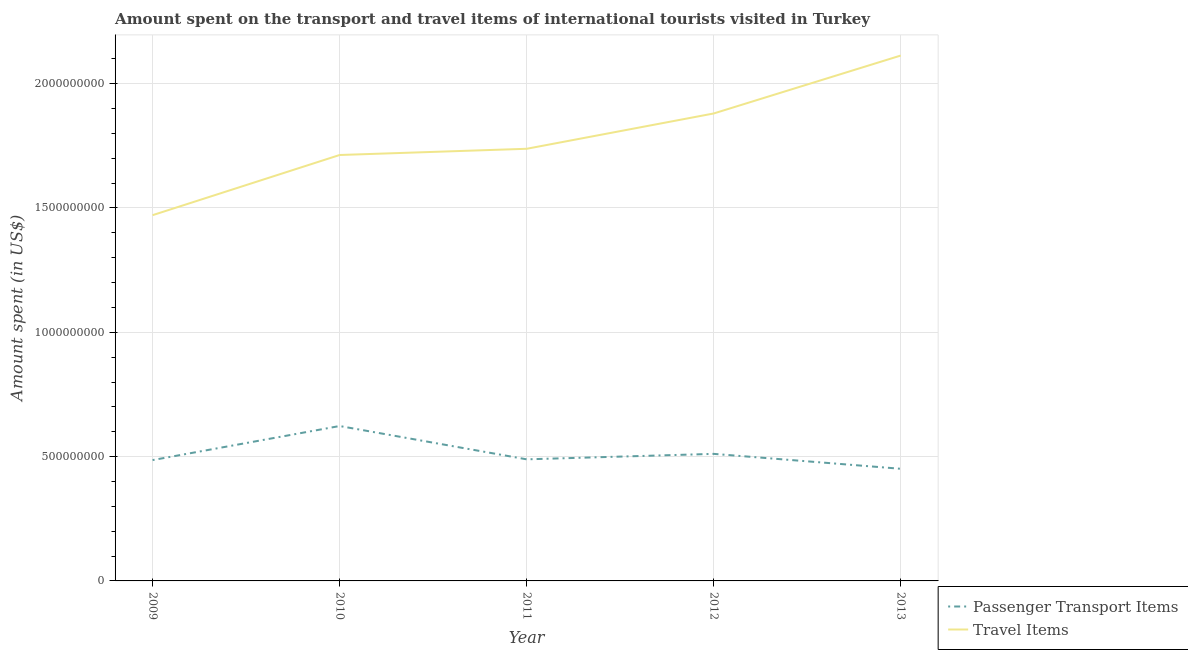How many different coloured lines are there?
Your answer should be compact. 2. Does the line corresponding to amount spent on passenger transport items intersect with the line corresponding to amount spent in travel items?
Provide a succinct answer. No. Is the number of lines equal to the number of legend labels?
Ensure brevity in your answer.  Yes. What is the amount spent on passenger transport items in 2010?
Your response must be concise. 6.23e+08. Across all years, what is the maximum amount spent on passenger transport items?
Give a very brief answer. 6.23e+08. Across all years, what is the minimum amount spent in travel items?
Your answer should be compact. 1.47e+09. What is the total amount spent in travel items in the graph?
Keep it short and to the point. 8.92e+09. What is the difference between the amount spent in travel items in 2010 and that in 2012?
Provide a succinct answer. -1.67e+08. What is the difference between the amount spent on passenger transport items in 2012 and the amount spent in travel items in 2010?
Make the answer very short. -1.20e+09. What is the average amount spent in travel items per year?
Offer a terse response. 1.78e+09. In the year 2011, what is the difference between the amount spent in travel items and amount spent on passenger transport items?
Keep it short and to the point. 1.25e+09. What is the ratio of the amount spent in travel items in 2010 to that in 2011?
Your response must be concise. 0.99. Is the difference between the amount spent in travel items in 2011 and 2012 greater than the difference between the amount spent on passenger transport items in 2011 and 2012?
Your answer should be very brief. No. What is the difference between the highest and the second highest amount spent in travel items?
Give a very brief answer. 2.33e+08. What is the difference between the highest and the lowest amount spent in travel items?
Provide a succinct answer. 6.42e+08. In how many years, is the amount spent on passenger transport items greater than the average amount spent on passenger transport items taken over all years?
Offer a very short reply. 1. Does the amount spent in travel items monotonically increase over the years?
Offer a terse response. Yes. Is the amount spent on passenger transport items strictly greater than the amount spent in travel items over the years?
Your response must be concise. No. How many lines are there?
Provide a short and direct response. 2. How many years are there in the graph?
Ensure brevity in your answer.  5. What is the difference between two consecutive major ticks on the Y-axis?
Your answer should be compact. 5.00e+08. Are the values on the major ticks of Y-axis written in scientific E-notation?
Your answer should be very brief. No. Does the graph contain any zero values?
Your answer should be very brief. No. Does the graph contain grids?
Ensure brevity in your answer.  Yes. Where does the legend appear in the graph?
Provide a short and direct response. Bottom right. How are the legend labels stacked?
Ensure brevity in your answer.  Vertical. What is the title of the graph?
Keep it short and to the point. Amount spent on the transport and travel items of international tourists visited in Turkey. What is the label or title of the X-axis?
Your answer should be very brief. Year. What is the label or title of the Y-axis?
Provide a short and direct response. Amount spent (in US$). What is the Amount spent (in US$) in Passenger Transport Items in 2009?
Provide a succinct answer. 4.86e+08. What is the Amount spent (in US$) in Travel Items in 2009?
Your answer should be compact. 1.47e+09. What is the Amount spent (in US$) in Passenger Transport Items in 2010?
Make the answer very short. 6.23e+08. What is the Amount spent (in US$) of Travel Items in 2010?
Offer a terse response. 1.71e+09. What is the Amount spent (in US$) of Passenger Transport Items in 2011?
Your response must be concise. 4.89e+08. What is the Amount spent (in US$) in Travel Items in 2011?
Offer a very short reply. 1.74e+09. What is the Amount spent (in US$) in Passenger Transport Items in 2012?
Offer a very short reply. 5.11e+08. What is the Amount spent (in US$) of Travel Items in 2012?
Offer a very short reply. 1.88e+09. What is the Amount spent (in US$) of Passenger Transport Items in 2013?
Make the answer very short. 4.51e+08. What is the Amount spent (in US$) in Travel Items in 2013?
Your answer should be very brief. 2.11e+09. Across all years, what is the maximum Amount spent (in US$) of Passenger Transport Items?
Provide a short and direct response. 6.23e+08. Across all years, what is the maximum Amount spent (in US$) of Travel Items?
Offer a terse response. 2.11e+09. Across all years, what is the minimum Amount spent (in US$) of Passenger Transport Items?
Your response must be concise. 4.51e+08. Across all years, what is the minimum Amount spent (in US$) of Travel Items?
Offer a very short reply. 1.47e+09. What is the total Amount spent (in US$) in Passenger Transport Items in the graph?
Make the answer very short. 2.56e+09. What is the total Amount spent (in US$) of Travel Items in the graph?
Your answer should be compact. 8.92e+09. What is the difference between the Amount spent (in US$) of Passenger Transport Items in 2009 and that in 2010?
Your response must be concise. -1.37e+08. What is the difference between the Amount spent (in US$) of Travel Items in 2009 and that in 2010?
Provide a short and direct response. -2.42e+08. What is the difference between the Amount spent (in US$) in Passenger Transport Items in 2009 and that in 2011?
Give a very brief answer. -3.00e+06. What is the difference between the Amount spent (in US$) of Travel Items in 2009 and that in 2011?
Your answer should be compact. -2.67e+08. What is the difference between the Amount spent (in US$) of Passenger Transport Items in 2009 and that in 2012?
Ensure brevity in your answer.  -2.50e+07. What is the difference between the Amount spent (in US$) in Travel Items in 2009 and that in 2012?
Your response must be concise. -4.09e+08. What is the difference between the Amount spent (in US$) of Passenger Transport Items in 2009 and that in 2013?
Make the answer very short. 3.50e+07. What is the difference between the Amount spent (in US$) in Travel Items in 2009 and that in 2013?
Your answer should be compact. -6.42e+08. What is the difference between the Amount spent (in US$) of Passenger Transport Items in 2010 and that in 2011?
Your answer should be very brief. 1.34e+08. What is the difference between the Amount spent (in US$) of Travel Items in 2010 and that in 2011?
Your answer should be compact. -2.50e+07. What is the difference between the Amount spent (in US$) of Passenger Transport Items in 2010 and that in 2012?
Provide a short and direct response. 1.12e+08. What is the difference between the Amount spent (in US$) in Travel Items in 2010 and that in 2012?
Keep it short and to the point. -1.67e+08. What is the difference between the Amount spent (in US$) of Passenger Transport Items in 2010 and that in 2013?
Your response must be concise. 1.72e+08. What is the difference between the Amount spent (in US$) in Travel Items in 2010 and that in 2013?
Offer a terse response. -4.00e+08. What is the difference between the Amount spent (in US$) in Passenger Transport Items in 2011 and that in 2012?
Offer a very short reply. -2.20e+07. What is the difference between the Amount spent (in US$) in Travel Items in 2011 and that in 2012?
Your response must be concise. -1.42e+08. What is the difference between the Amount spent (in US$) of Passenger Transport Items in 2011 and that in 2013?
Your answer should be very brief. 3.80e+07. What is the difference between the Amount spent (in US$) in Travel Items in 2011 and that in 2013?
Keep it short and to the point. -3.75e+08. What is the difference between the Amount spent (in US$) in Passenger Transport Items in 2012 and that in 2013?
Offer a terse response. 6.00e+07. What is the difference between the Amount spent (in US$) in Travel Items in 2012 and that in 2013?
Your answer should be very brief. -2.33e+08. What is the difference between the Amount spent (in US$) of Passenger Transport Items in 2009 and the Amount spent (in US$) of Travel Items in 2010?
Your answer should be very brief. -1.23e+09. What is the difference between the Amount spent (in US$) of Passenger Transport Items in 2009 and the Amount spent (in US$) of Travel Items in 2011?
Ensure brevity in your answer.  -1.25e+09. What is the difference between the Amount spent (in US$) in Passenger Transport Items in 2009 and the Amount spent (in US$) in Travel Items in 2012?
Offer a terse response. -1.39e+09. What is the difference between the Amount spent (in US$) in Passenger Transport Items in 2009 and the Amount spent (in US$) in Travel Items in 2013?
Ensure brevity in your answer.  -1.63e+09. What is the difference between the Amount spent (in US$) in Passenger Transport Items in 2010 and the Amount spent (in US$) in Travel Items in 2011?
Offer a very short reply. -1.12e+09. What is the difference between the Amount spent (in US$) in Passenger Transport Items in 2010 and the Amount spent (in US$) in Travel Items in 2012?
Offer a terse response. -1.26e+09. What is the difference between the Amount spent (in US$) of Passenger Transport Items in 2010 and the Amount spent (in US$) of Travel Items in 2013?
Offer a very short reply. -1.49e+09. What is the difference between the Amount spent (in US$) of Passenger Transport Items in 2011 and the Amount spent (in US$) of Travel Items in 2012?
Keep it short and to the point. -1.39e+09. What is the difference between the Amount spent (in US$) of Passenger Transport Items in 2011 and the Amount spent (in US$) of Travel Items in 2013?
Provide a short and direct response. -1.62e+09. What is the difference between the Amount spent (in US$) of Passenger Transport Items in 2012 and the Amount spent (in US$) of Travel Items in 2013?
Make the answer very short. -1.60e+09. What is the average Amount spent (in US$) in Passenger Transport Items per year?
Ensure brevity in your answer.  5.12e+08. What is the average Amount spent (in US$) of Travel Items per year?
Offer a terse response. 1.78e+09. In the year 2009, what is the difference between the Amount spent (in US$) of Passenger Transport Items and Amount spent (in US$) of Travel Items?
Give a very brief answer. -9.85e+08. In the year 2010, what is the difference between the Amount spent (in US$) of Passenger Transport Items and Amount spent (in US$) of Travel Items?
Your answer should be very brief. -1.09e+09. In the year 2011, what is the difference between the Amount spent (in US$) in Passenger Transport Items and Amount spent (in US$) in Travel Items?
Your answer should be very brief. -1.25e+09. In the year 2012, what is the difference between the Amount spent (in US$) of Passenger Transport Items and Amount spent (in US$) of Travel Items?
Your response must be concise. -1.37e+09. In the year 2013, what is the difference between the Amount spent (in US$) of Passenger Transport Items and Amount spent (in US$) of Travel Items?
Provide a short and direct response. -1.66e+09. What is the ratio of the Amount spent (in US$) in Passenger Transport Items in 2009 to that in 2010?
Your answer should be compact. 0.78. What is the ratio of the Amount spent (in US$) of Travel Items in 2009 to that in 2010?
Give a very brief answer. 0.86. What is the ratio of the Amount spent (in US$) in Travel Items in 2009 to that in 2011?
Offer a terse response. 0.85. What is the ratio of the Amount spent (in US$) of Passenger Transport Items in 2009 to that in 2012?
Offer a terse response. 0.95. What is the ratio of the Amount spent (in US$) of Travel Items in 2009 to that in 2012?
Keep it short and to the point. 0.78. What is the ratio of the Amount spent (in US$) of Passenger Transport Items in 2009 to that in 2013?
Make the answer very short. 1.08. What is the ratio of the Amount spent (in US$) of Travel Items in 2009 to that in 2013?
Offer a very short reply. 0.7. What is the ratio of the Amount spent (in US$) in Passenger Transport Items in 2010 to that in 2011?
Make the answer very short. 1.27. What is the ratio of the Amount spent (in US$) of Travel Items in 2010 to that in 2011?
Your answer should be very brief. 0.99. What is the ratio of the Amount spent (in US$) of Passenger Transport Items in 2010 to that in 2012?
Provide a succinct answer. 1.22. What is the ratio of the Amount spent (in US$) in Travel Items in 2010 to that in 2012?
Give a very brief answer. 0.91. What is the ratio of the Amount spent (in US$) of Passenger Transport Items in 2010 to that in 2013?
Ensure brevity in your answer.  1.38. What is the ratio of the Amount spent (in US$) of Travel Items in 2010 to that in 2013?
Provide a short and direct response. 0.81. What is the ratio of the Amount spent (in US$) of Passenger Transport Items in 2011 to that in 2012?
Your response must be concise. 0.96. What is the ratio of the Amount spent (in US$) in Travel Items in 2011 to that in 2012?
Your answer should be compact. 0.92. What is the ratio of the Amount spent (in US$) in Passenger Transport Items in 2011 to that in 2013?
Ensure brevity in your answer.  1.08. What is the ratio of the Amount spent (in US$) in Travel Items in 2011 to that in 2013?
Your answer should be compact. 0.82. What is the ratio of the Amount spent (in US$) in Passenger Transport Items in 2012 to that in 2013?
Make the answer very short. 1.13. What is the ratio of the Amount spent (in US$) of Travel Items in 2012 to that in 2013?
Ensure brevity in your answer.  0.89. What is the difference between the highest and the second highest Amount spent (in US$) in Passenger Transport Items?
Offer a very short reply. 1.12e+08. What is the difference between the highest and the second highest Amount spent (in US$) of Travel Items?
Provide a short and direct response. 2.33e+08. What is the difference between the highest and the lowest Amount spent (in US$) of Passenger Transport Items?
Your response must be concise. 1.72e+08. What is the difference between the highest and the lowest Amount spent (in US$) in Travel Items?
Provide a short and direct response. 6.42e+08. 